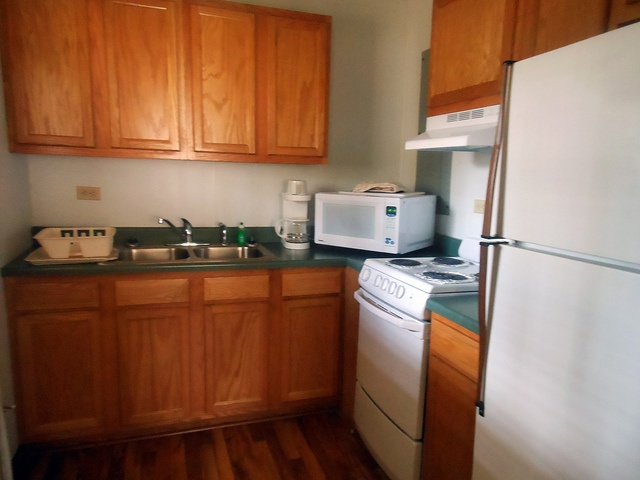Describe the objects in this image and their specific colors. I can see refrigerator in maroon, lightgray, and darkgray tones, oven in maroon, brown, lavender, darkgray, and gray tones, microwave in maroon, darkgray, lightgray, and gray tones, sink in maroon, black, and gray tones, and bottle in maroon and darkgreen tones in this image. 